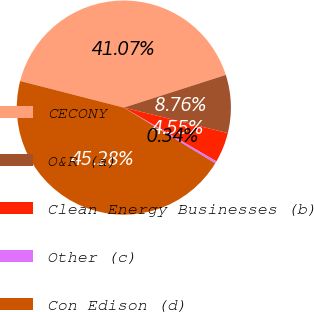<chart> <loc_0><loc_0><loc_500><loc_500><pie_chart><fcel>CECONY<fcel>O&R (a)<fcel>Clean Energy Businesses (b)<fcel>Other (c)<fcel>Con Edison (d)<nl><fcel>41.07%<fcel>8.76%<fcel>4.55%<fcel>0.34%<fcel>45.28%<nl></chart> 